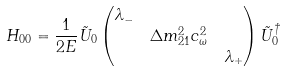<formula> <loc_0><loc_0><loc_500><loc_500>H _ { 0 0 } & = \frac { 1 } { 2 E } \tilde { U } _ { 0 } \begin{pmatrix} \lambda _ { - } & & \\ & \Delta m _ { 2 1 } ^ { 2 } c _ { \omega } ^ { 2 } & \\ & & \lambda _ { + } \end{pmatrix} \tilde { U } _ { 0 } ^ { \dagger }</formula> 